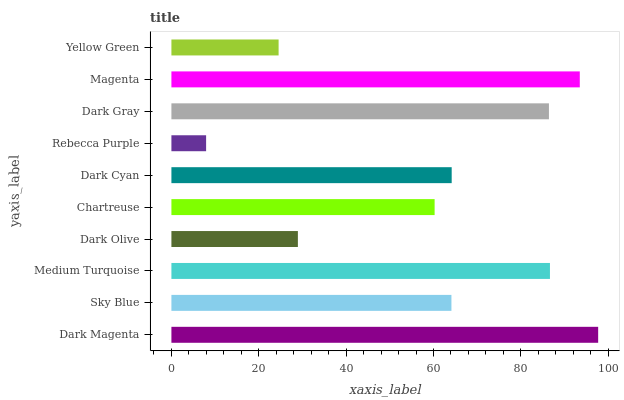Is Rebecca Purple the minimum?
Answer yes or no. Yes. Is Dark Magenta the maximum?
Answer yes or no. Yes. Is Sky Blue the minimum?
Answer yes or no. No. Is Sky Blue the maximum?
Answer yes or no. No. Is Dark Magenta greater than Sky Blue?
Answer yes or no. Yes. Is Sky Blue less than Dark Magenta?
Answer yes or no. Yes. Is Sky Blue greater than Dark Magenta?
Answer yes or no. No. Is Dark Magenta less than Sky Blue?
Answer yes or no. No. Is Dark Cyan the high median?
Answer yes or no. Yes. Is Sky Blue the low median?
Answer yes or no. Yes. Is Chartreuse the high median?
Answer yes or no. No. Is Yellow Green the low median?
Answer yes or no. No. 